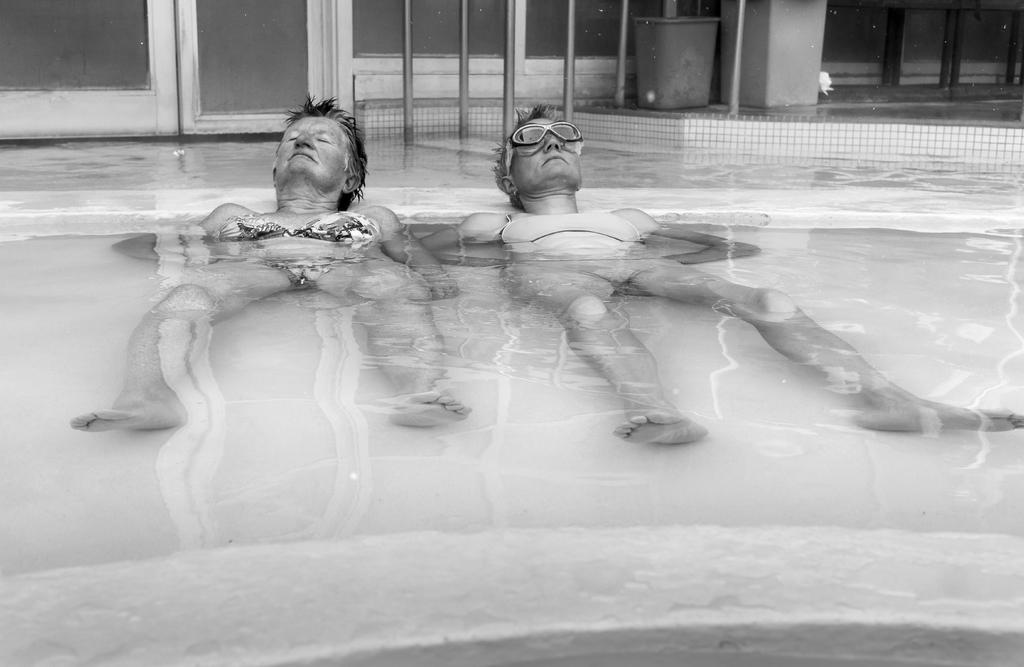What are the two persons in the image doing? The two persons are lying in the water. What object can be seen near the water? There is a bucket visible in the image. What structures are present in the image? Poles and a pillar are visible in the image. What architectural feature is present in the image? There is a window in the image. What type of pet can be seen playing with the persons in the image? There is no pet present in the image; it only features two persons lying in the water and various objects and structures. What is the way the persons are using to communicate with each other in the image? The image does not show any specific way of communication between the persons; they are simply lying in the water. 